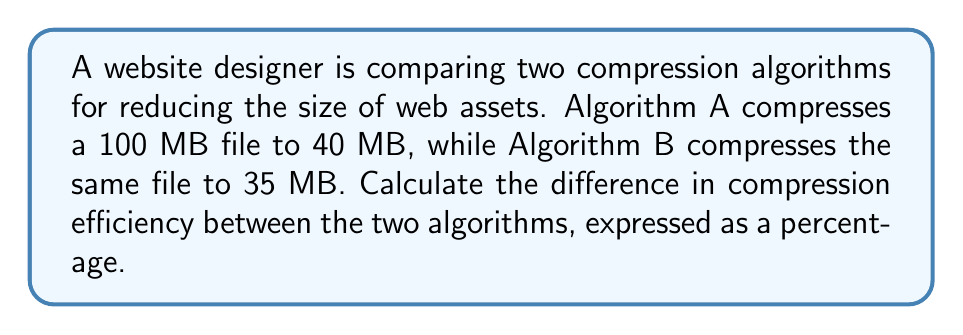Could you help me with this problem? Let's approach this step-by-step:

1. Calculate the compression ratio for Algorithm A:
   $$ \text{Ratio}_A = \frac{\text{Compressed size}}{\text{Original size}} = \frac{40 \text{ MB}}{100 \text{ MB}} = 0.4 $$

2. Calculate the compression ratio for Algorithm B:
   $$ \text{Ratio}_B = \frac{\text{Compressed size}}{\text{Original size}} = \frac{35 \text{ MB}}{100 \text{ MB}} = 0.35 $$

3. Calculate the compression efficiency for each algorithm:
   $$ \text{Efficiency} = (1 - \text{Compression Ratio}) \times 100\% $$

   For Algorithm A:
   $$ \text{Efficiency}_A = (1 - 0.4) \times 100\% = 60\% $$

   For Algorithm B:
   $$ \text{Efficiency}_B = (1 - 0.35) \times 100\% = 65\% $$

4. Calculate the difference in efficiency:
   $$ \text{Difference} = \text{Efficiency}_B - \text{Efficiency}_A = 65\% - 60\% = 5\% $$

Therefore, the difference in compression efficiency between Algorithm B and Algorithm A is 5%.
Answer: 5% 